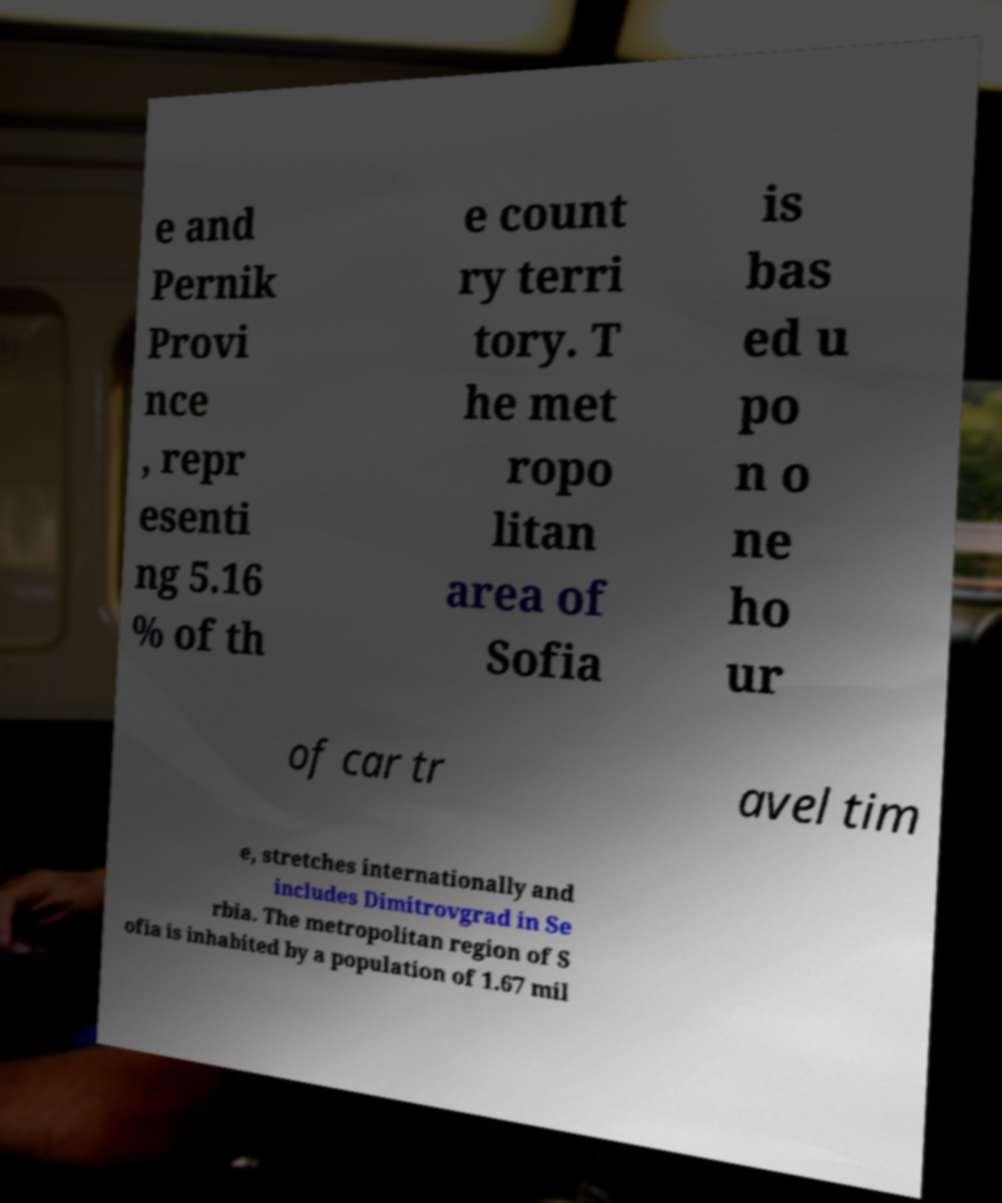There's text embedded in this image that I need extracted. Can you transcribe it verbatim? e and Pernik Provi nce , repr esenti ng 5.16 % of th e count ry terri tory. T he met ropo litan area of Sofia is bas ed u po n o ne ho ur of car tr avel tim e, stretches internationally and includes Dimitrovgrad in Se rbia. The metropolitan region of S ofia is inhabited by a population of 1.67 mil 